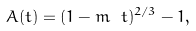Convert formula to latex. <formula><loc_0><loc_0><loc_500><loc_500>A ( t ) = ( 1 - m \ t ) ^ { 2 / 3 } - 1 ,</formula> 